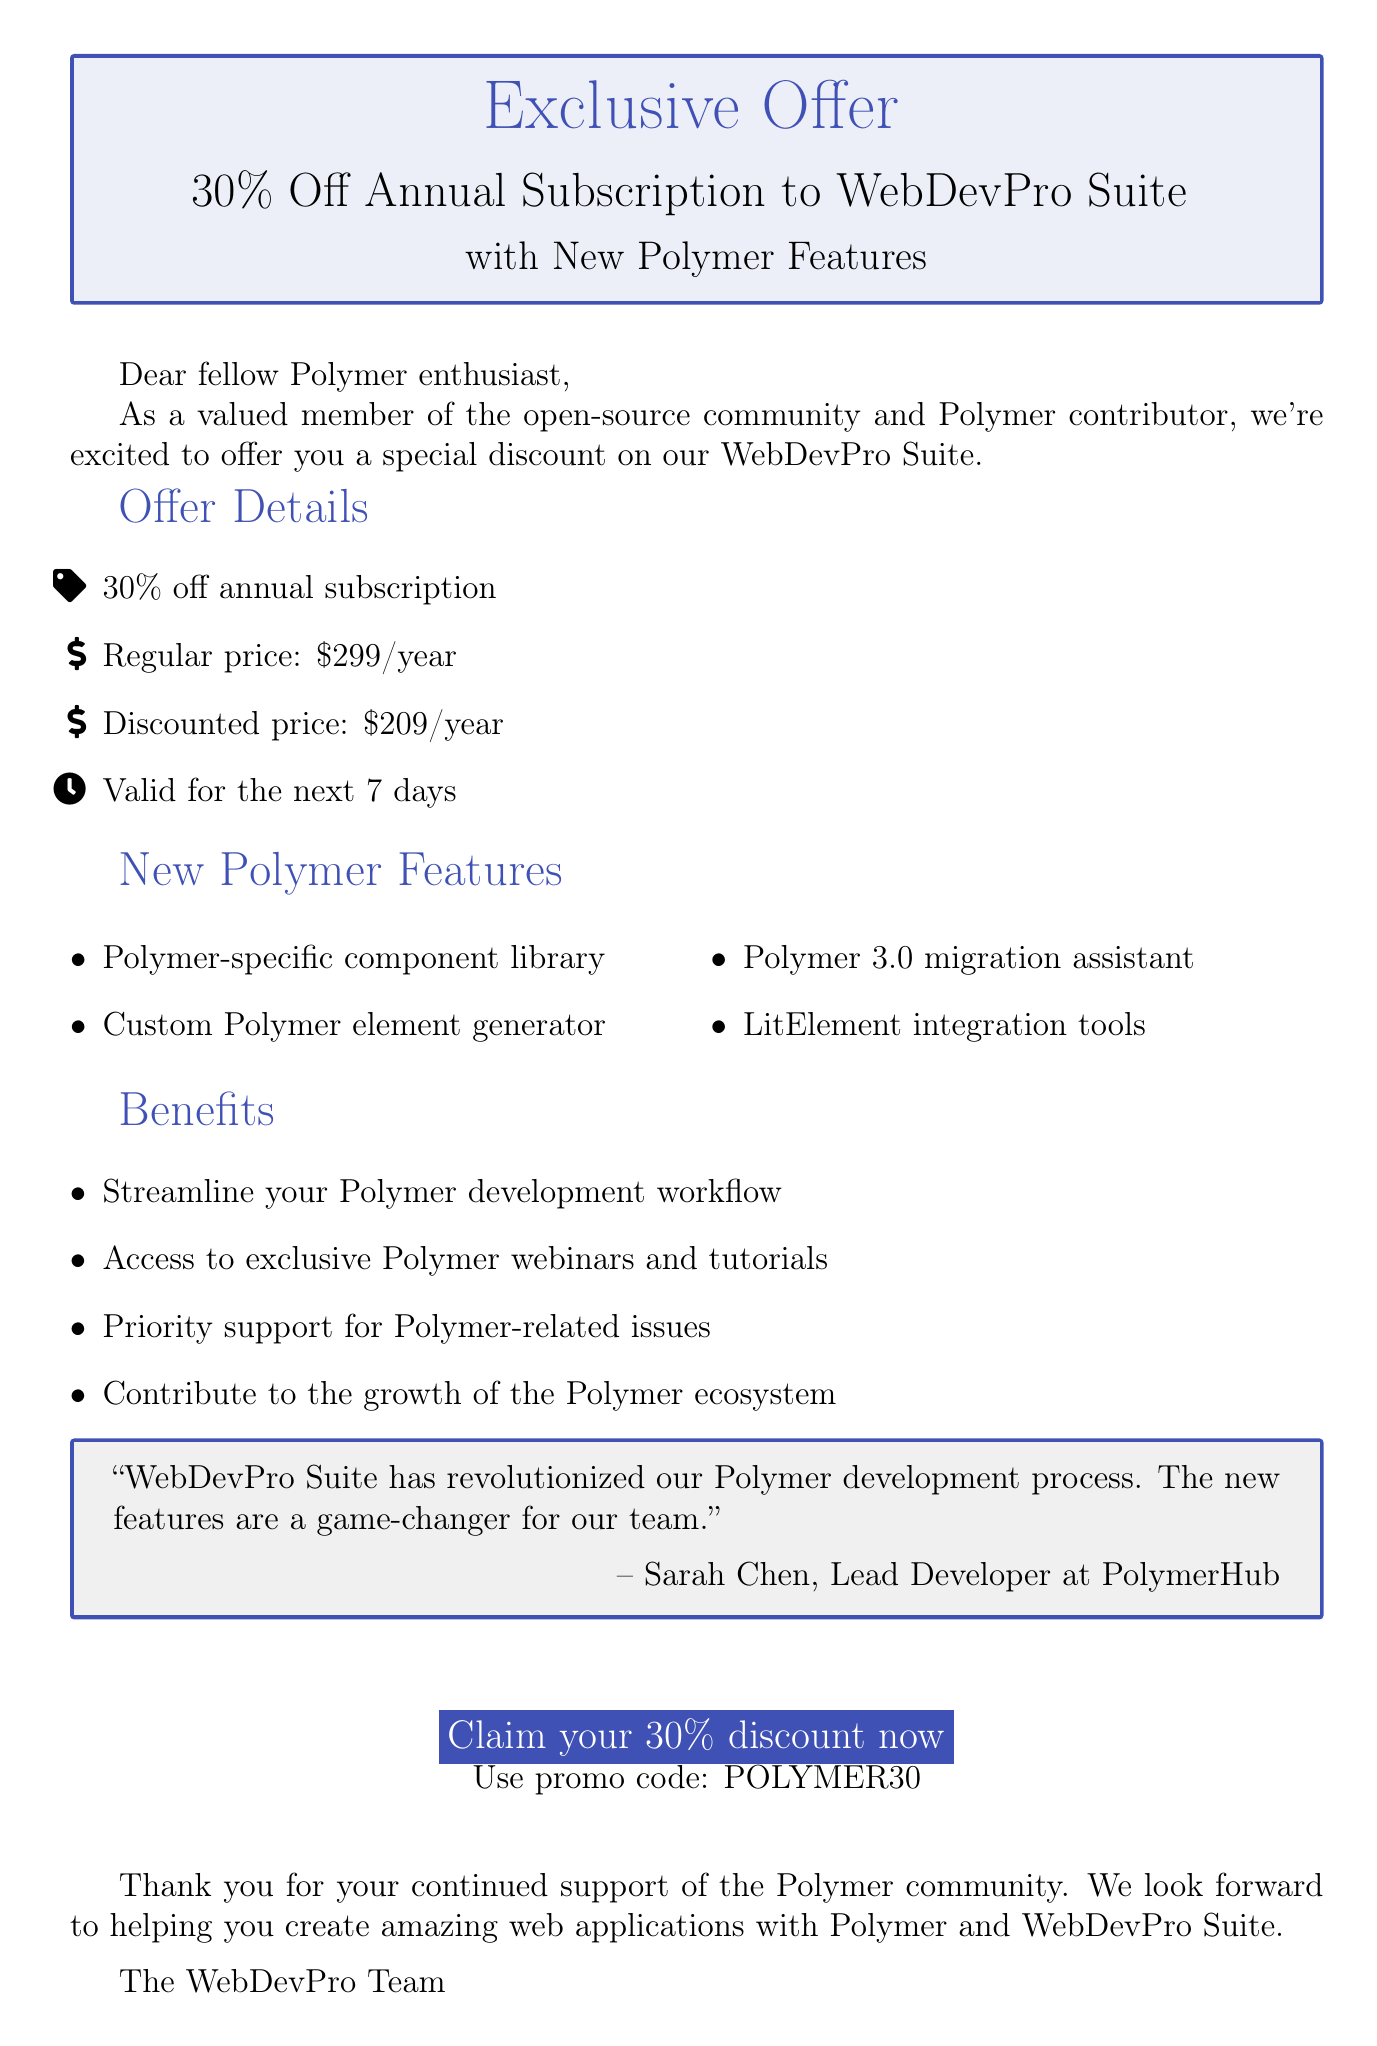What is the discount percentage offered? The document states that the discount percentage is 30% off the annual subscription.
Answer: 30% What is the regular price of the subscription? The regular price of the WebDevPro Suite annual subscription is given as $299/year.
Answer: $299/year What is the discounted price of the subscription? The document specifies the discounted price of the subscription after applying the discount is $209/year.
Answer: $209/year How long is the offer valid? The offer duration mentioned in the document is valid for the next 7 days.
Answer: 7 days What new feature helps with Polymer 3.0? The document lists a specific feature, the Polymer 3.0 migration assistant, that helps with Polymer 3.0.
Answer: Polymer 3.0 migration assistant Who provided the testimonial in the document? The testimonial is attributed to Sarah Chen, who is identified as the Lead Developer at PolymerHub.
Answer: Sarah Chen What is the purpose of the promo code mentioned? The promo code POLYMER30 is provided for claiming the 30% discount on the subscription.
Answer: POLYMER30 What type of team supports Polymer-related issues? The document mentions that the subscription provides priority support for Polymer-related issues.
Answer: Priority support What do users gain access to aside from the tool suite? Users also gain access to exclusive Polymer webinars and tutorials as a benefit of the subscription.
Answer: Exclusive Polymer webinars and tutorials 